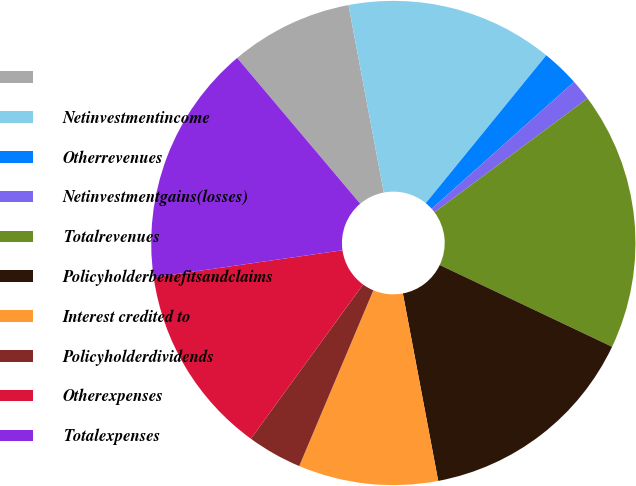<chart> <loc_0><loc_0><loc_500><loc_500><pie_chart><ecel><fcel>Netinvestmentincome<fcel>Otherrevenues<fcel>Netinvestmentgains(losses)<fcel>Totalrevenues<fcel>Policyholderbenefitsandclaims<fcel>Interest credited to<fcel>Policyholderdividends<fcel>Otherexpenses<fcel>Totalexpenses<nl><fcel>8.19%<fcel>13.85%<fcel>2.53%<fcel>1.4%<fcel>17.24%<fcel>14.98%<fcel>9.32%<fcel>3.66%<fcel>12.72%<fcel>16.11%<nl></chart> 